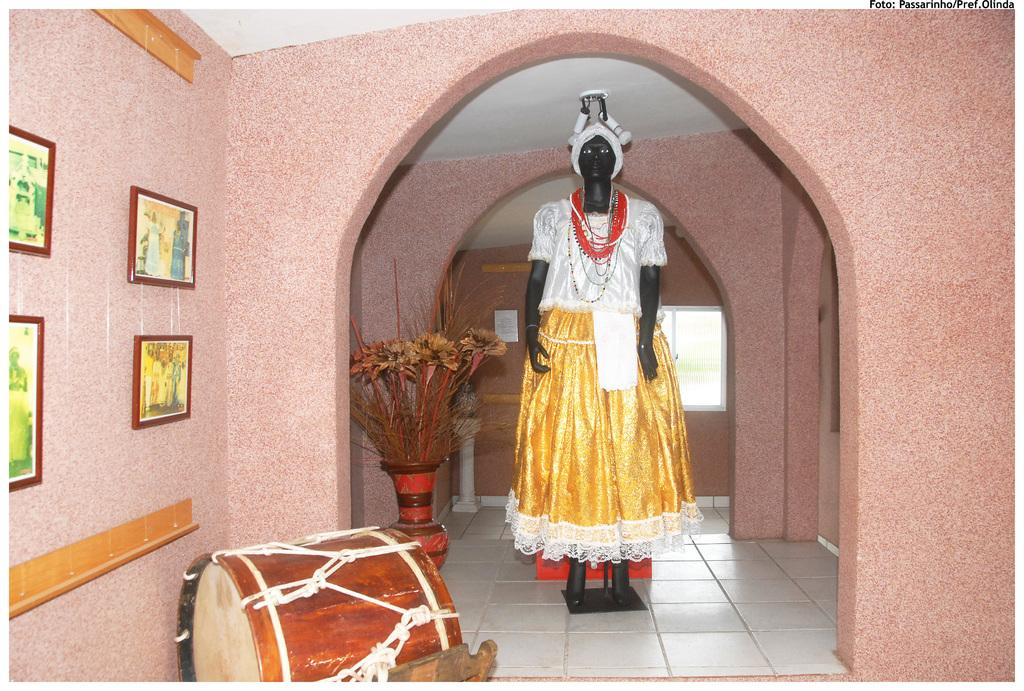What is located at the left side of the image? There is a doll standing at the left side of the image. What can be seen attached to the wall in the image? There are frames attached to a wall in the image. What is visible in the background of the image? There is a flower pot in the background of the image. What type of territory is being claimed by the doll in the image? The doll is not claiming any territory in the image; it is simply standing at the left side. 